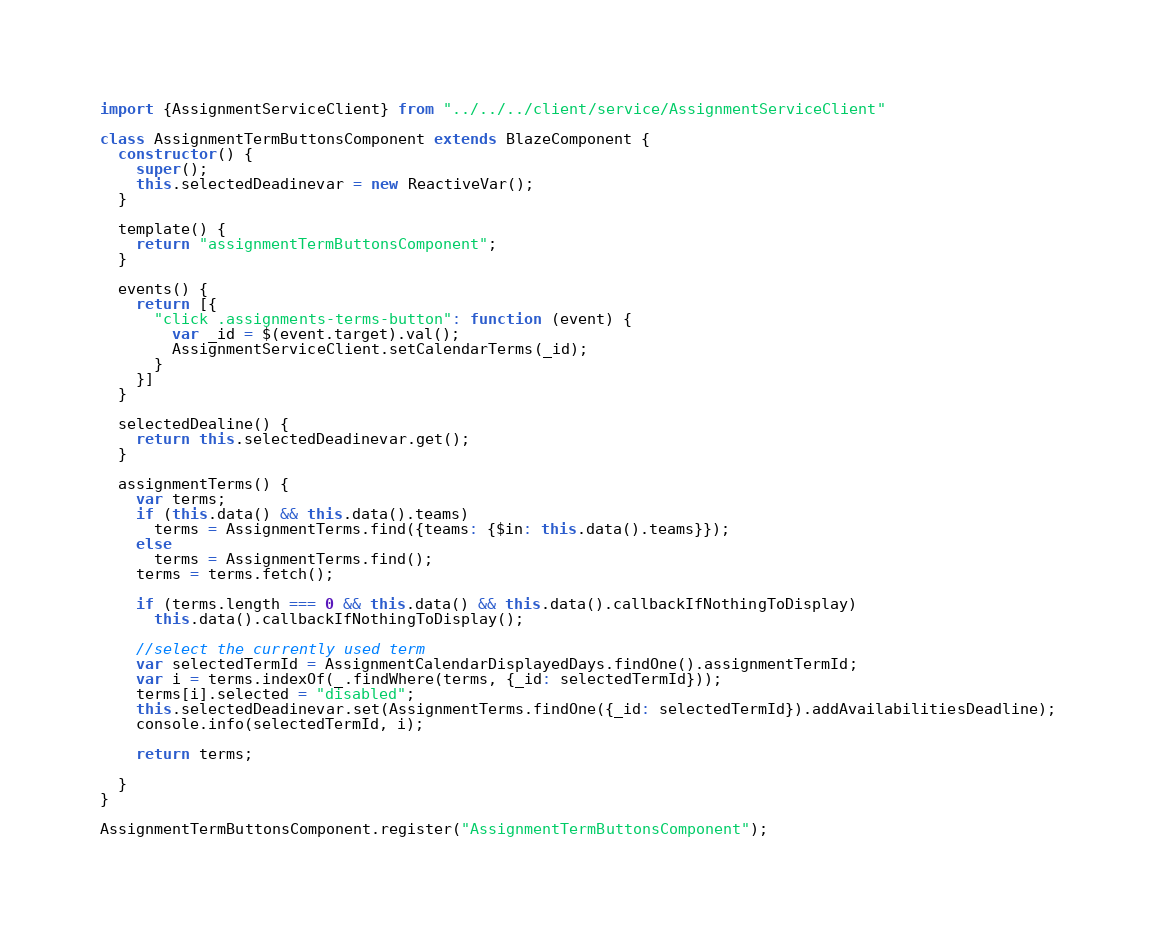Convert code to text. <code><loc_0><loc_0><loc_500><loc_500><_JavaScript_>import {AssignmentServiceClient} from "../../../client/service/AssignmentServiceClient"

class AssignmentTermButtonsComponent extends BlazeComponent {
  constructor() {
    super();
    this.selectedDeadinevar = new ReactiveVar();
  }

  template() {
    return "assignmentTermButtonsComponent";
  }

  events() {
    return [{
      "click .assignments-terms-button": function (event) {
        var _id = $(event.target).val();
        AssignmentServiceClient.setCalendarTerms(_id);
      }
    }]
  }

  selectedDealine() {
    return this.selectedDeadinevar.get();
  }

  assignmentTerms() {
    var terms;
    if (this.data() && this.data().teams)
      terms = AssignmentTerms.find({teams: {$in: this.data().teams}});
    else
      terms = AssignmentTerms.find();
    terms = terms.fetch();

    if (terms.length === 0 && this.data() && this.data().callbackIfNothingToDisplay)
      this.data().callbackIfNothingToDisplay();

    //select the currently used term
    var selectedTermId = AssignmentCalendarDisplayedDays.findOne().assignmentTermId;
    var i = terms.indexOf(_.findWhere(terms, {_id: selectedTermId}));
    terms[i].selected = "disabled";
    this.selectedDeadinevar.set(AssignmentTerms.findOne({_id: selectedTermId}).addAvailabilitiesDeadline);
    console.info(selectedTermId, i);

    return terms;

  }
}

AssignmentTermButtonsComponent.register("AssignmentTermButtonsComponent");</code> 